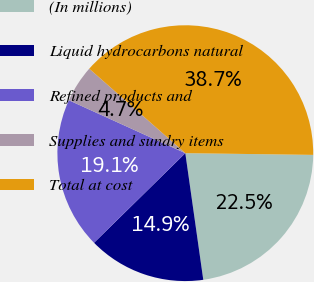Convert chart. <chart><loc_0><loc_0><loc_500><loc_500><pie_chart><fcel>(In millions)<fcel>Liquid hydrocarbons natural<fcel>Refined products and<fcel>Supplies and sundry items<fcel>Total at cost<nl><fcel>22.54%<fcel>14.89%<fcel>19.14%<fcel>4.69%<fcel>38.73%<nl></chart> 